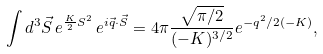Convert formula to latex. <formula><loc_0><loc_0><loc_500><loc_500>\int d ^ { 3 } \vec { S } \, e ^ { \frac { K } { 2 } S ^ { 2 } } \, e ^ { i \vec { q } \cdot \vec { S } } = 4 \pi \frac { \sqrt { \pi / 2 } } { ( - K ) ^ { 3 / 2 } } e ^ { - q ^ { 2 } / 2 ( - K ) } ,</formula> 